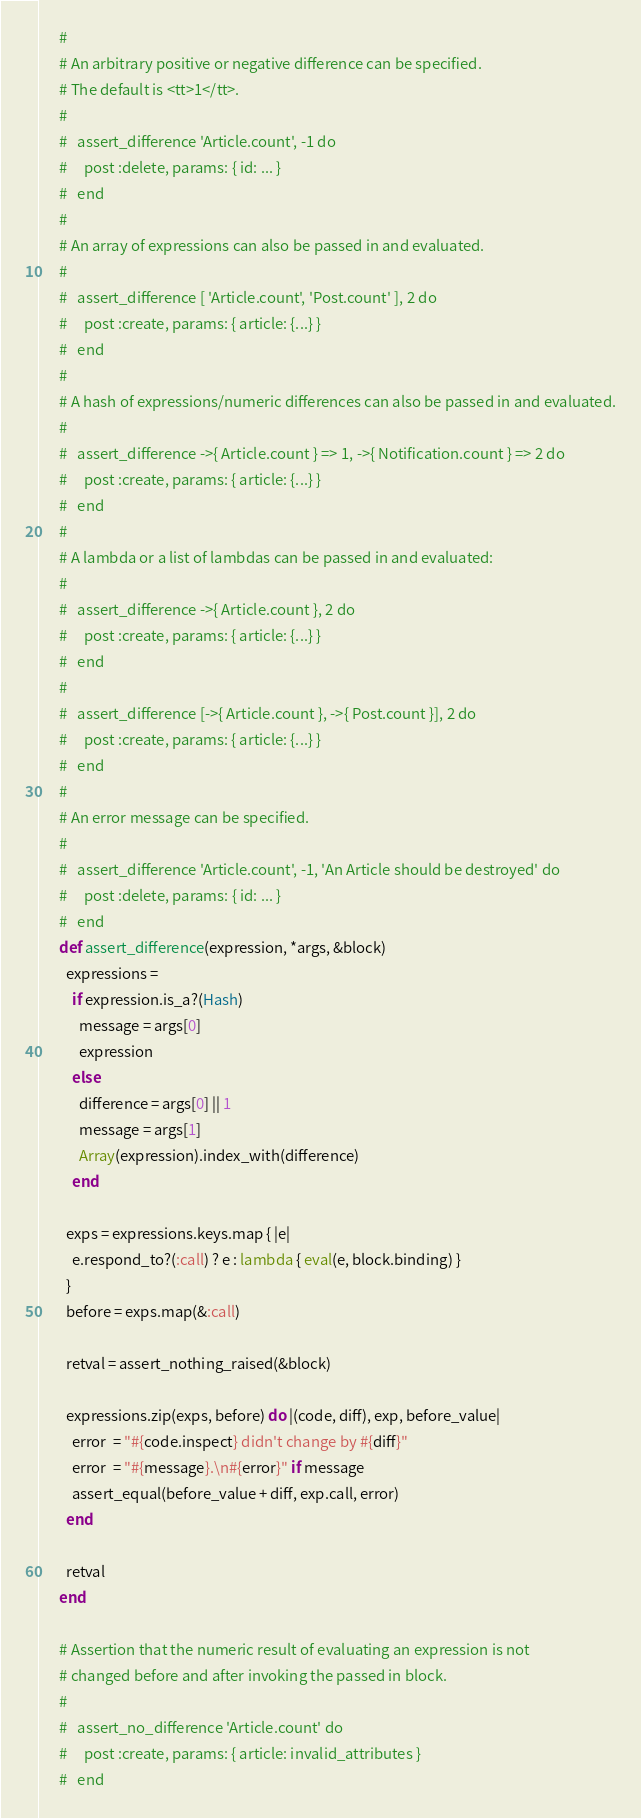Convert code to text. <code><loc_0><loc_0><loc_500><loc_500><_Ruby_>      #
      # An arbitrary positive or negative difference can be specified.
      # The default is <tt>1</tt>.
      #
      #   assert_difference 'Article.count', -1 do
      #     post :delete, params: { id: ... }
      #   end
      #
      # An array of expressions can also be passed in and evaluated.
      #
      #   assert_difference [ 'Article.count', 'Post.count' ], 2 do
      #     post :create, params: { article: {...} }
      #   end
      #
      # A hash of expressions/numeric differences can also be passed in and evaluated.
      #
      #   assert_difference ->{ Article.count } => 1, ->{ Notification.count } => 2 do
      #     post :create, params: { article: {...} }
      #   end
      #
      # A lambda or a list of lambdas can be passed in and evaluated:
      #
      #   assert_difference ->{ Article.count }, 2 do
      #     post :create, params: { article: {...} }
      #   end
      #
      #   assert_difference [->{ Article.count }, ->{ Post.count }], 2 do
      #     post :create, params: { article: {...} }
      #   end
      #
      # An error message can be specified.
      #
      #   assert_difference 'Article.count', -1, 'An Article should be destroyed' do
      #     post :delete, params: { id: ... }
      #   end
      def assert_difference(expression, *args, &block)
        expressions =
          if expression.is_a?(Hash)
            message = args[0]
            expression
          else
            difference = args[0] || 1
            message = args[1]
            Array(expression).index_with(difference)
          end

        exps = expressions.keys.map { |e|
          e.respond_to?(:call) ? e : lambda { eval(e, block.binding) }
        }
        before = exps.map(&:call)

        retval = assert_nothing_raised(&block)

        expressions.zip(exps, before) do |(code, diff), exp, before_value|
          error  = "#{code.inspect} didn't change by #{diff}"
          error  = "#{message}.\n#{error}" if message
          assert_equal(before_value + diff, exp.call, error)
        end

        retval
      end

      # Assertion that the numeric result of evaluating an expression is not
      # changed before and after invoking the passed in block.
      #
      #   assert_no_difference 'Article.count' do
      #     post :create, params: { article: invalid_attributes }
      #   end</code> 